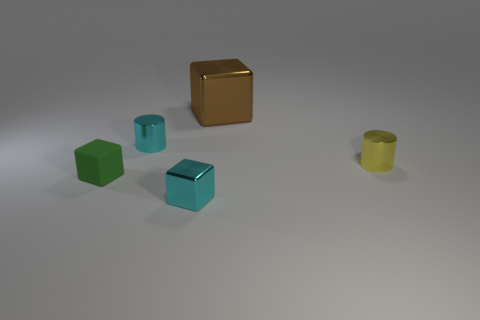Add 5 green rubber cubes. How many objects exist? 10 Subtract all blocks. How many objects are left? 2 Add 1 tiny green matte cubes. How many tiny green matte cubes exist? 2 Subtract 0 gray cubes. How many objects are left? 5 Subtract all small yellow matte balls. Subtract all cyan metallic cubes. How many objects are left? 4 Add 2 brown blocks. How many brown blocks are left? 3 